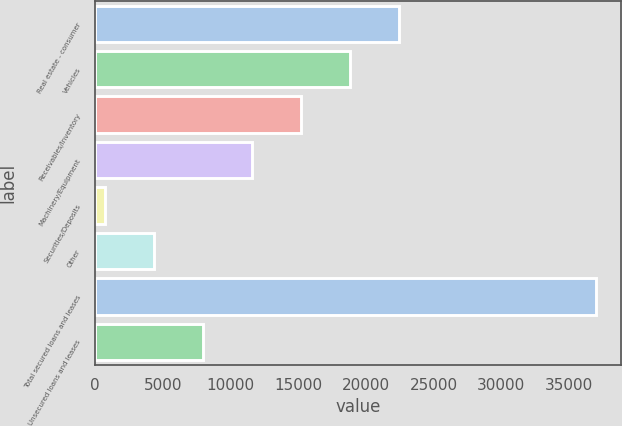Convert chart to OTSL. <chart><loc_0><loc_0><loc_500><loc_500><bar_chart><fcel>Real estate - consumer<fcel>Vehicles<fcel>Receivables/Inventory<fcel>Machinery/Equipment<fcel>Securities/Deposits<fcel>Other<fcel>Total secured loans and leases<fcel>Unsecured loans and leases<nl><fcel>22487.6<fcel>18862<fcel>15236.4<fcel>11610.8<fcel>734<fcel>4359.6<fcel>36990<fcel>7985.2<nl></chart> 